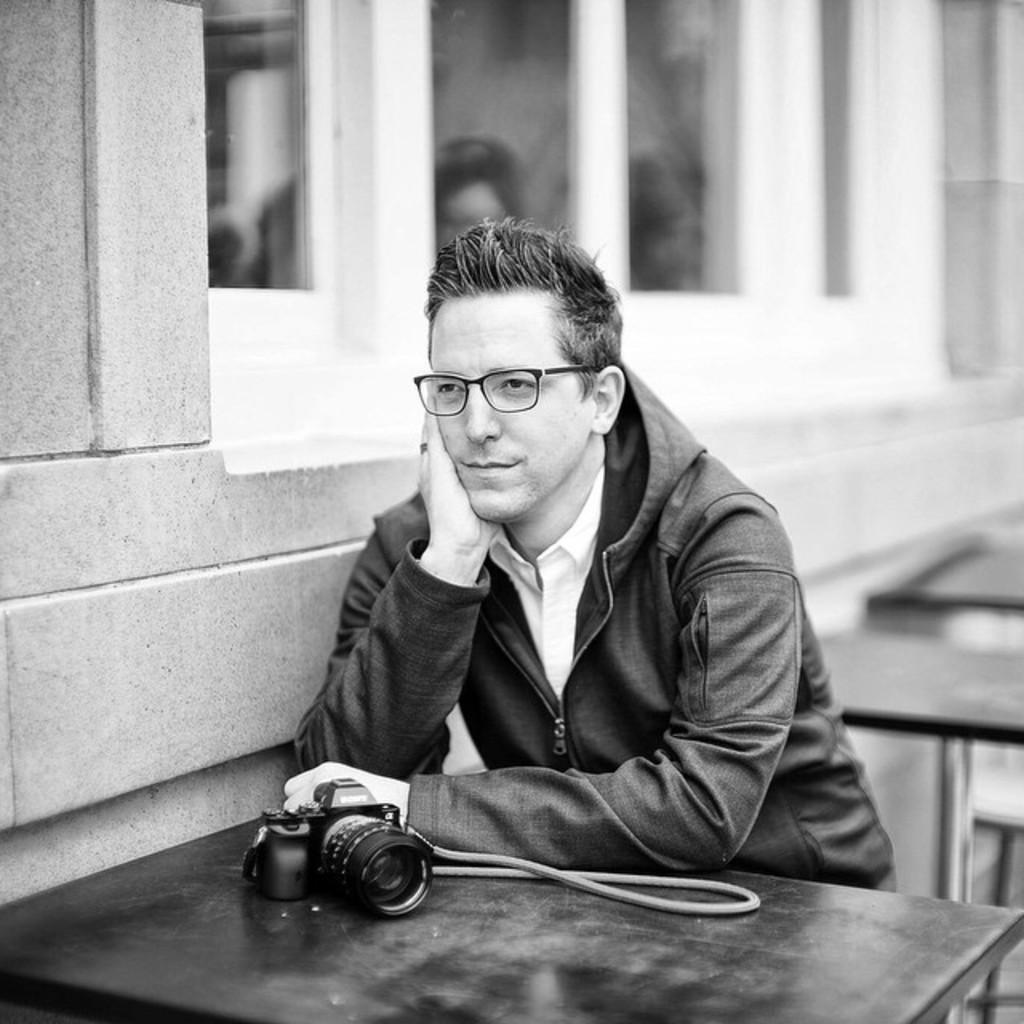Can you describe this image briefly? This is a black and white image. We can see a person sitting. We can also see some tables and a camera. Behind the person, we can see a wall and a window. 